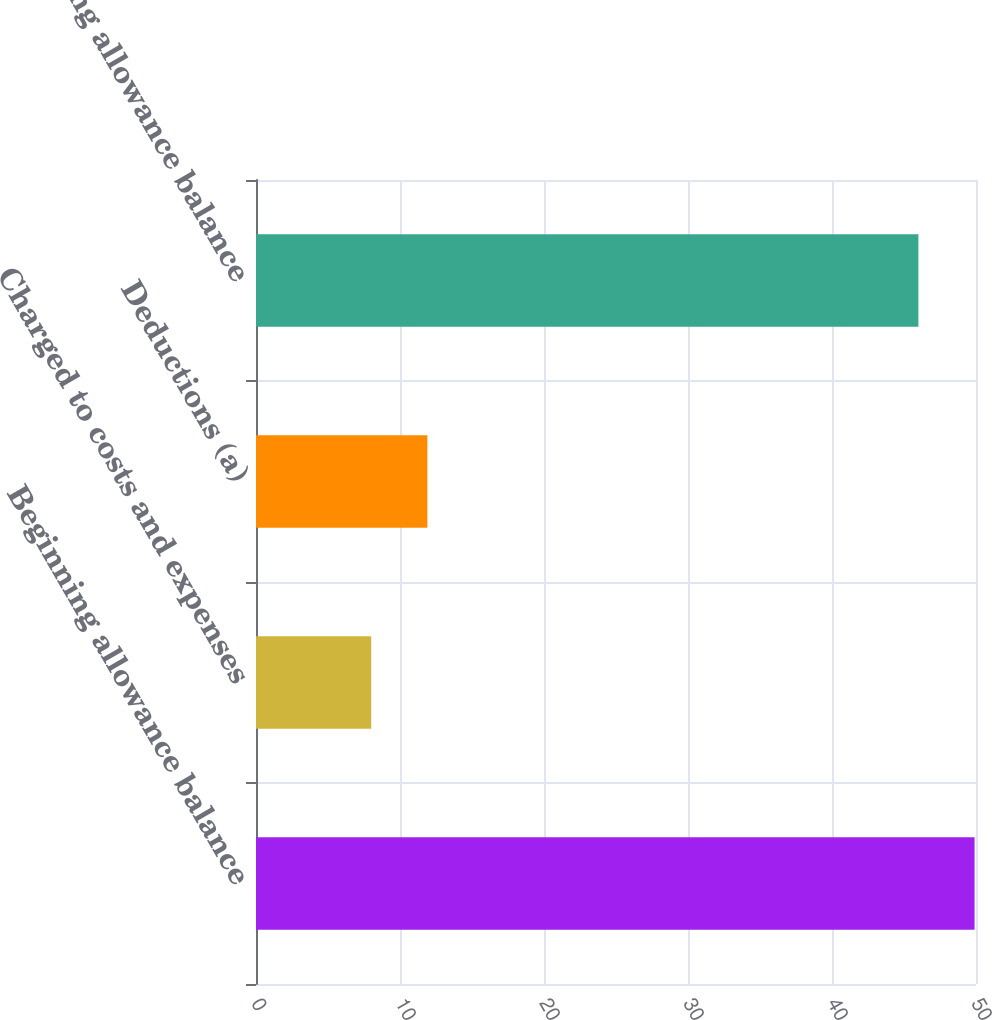Convert chart to OTSL. <chart><loc_0><loc_0><loc_500><loc_500><bar_chart><fcel>Beginning allowance balance<fcel>Charged to costs and expenses<fcel>Deductions (a)<fcel>Ending allowance balance<nl><fcel>49.9<fcel>8<fcel>11.9<fcel>46<nl></chart> 